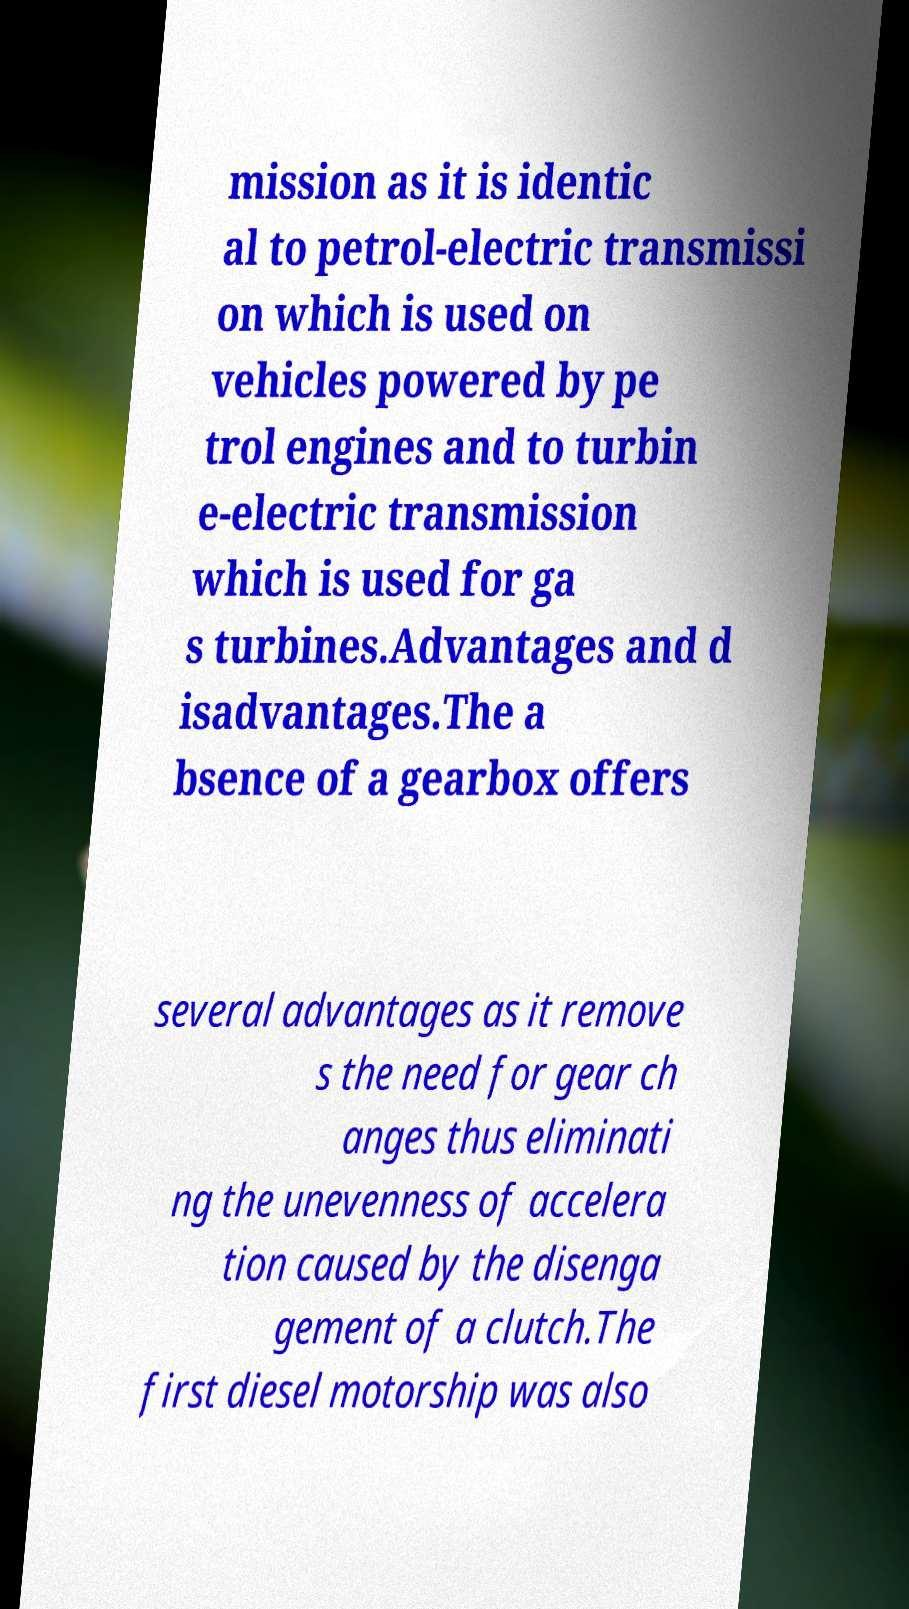Can you read and provide the text displayed in the image?This photo seems to have some interesting text. Can you extract and type it out for me? mission as it is identic al to petrol-electric transmissi on which is used on vehicles powered by pe trol engines and to turbin e-electric transmission which is used for ga s turbines.Advantages and d isadvantages.The a bsence of a gearbox offers several advantages as it remove s the need for gear ch anges thus eliminati ng the unevenness of accelera tion caused by the disenga gement of a clutch.The first diesel motorship was also 